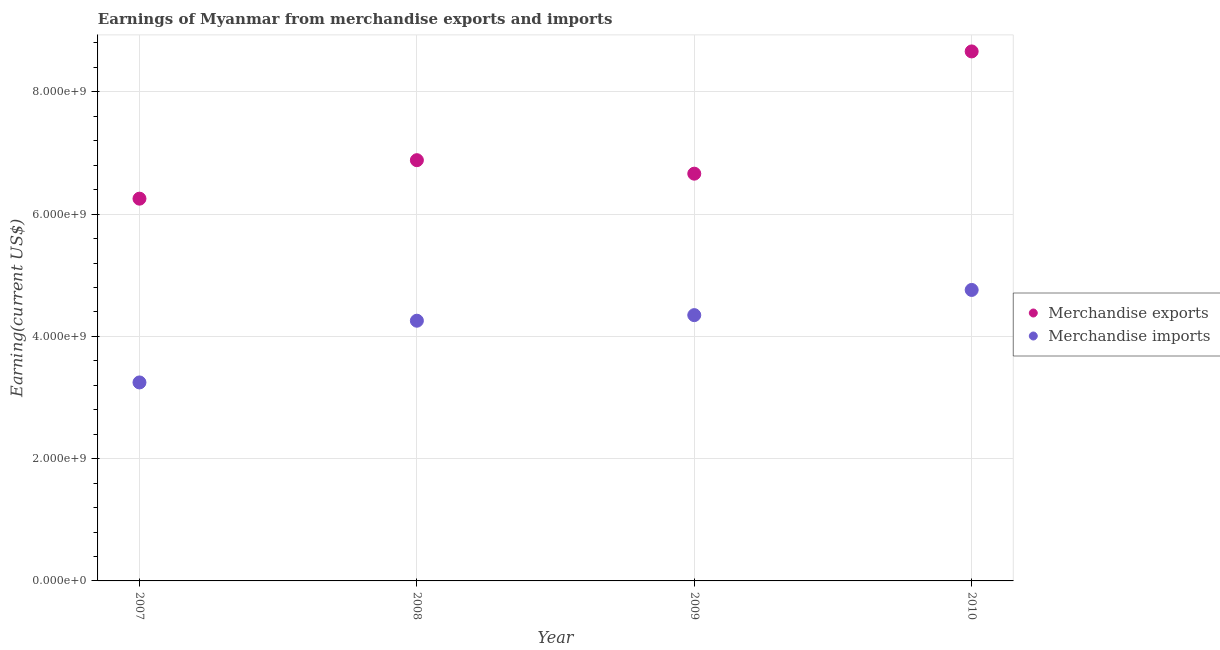How many different coloured dotlines are there?
Ensure brevity in your answer.  2. What is the earnings from merchandise exports in 2010?
Offer a terse response. 8.66e+09. Across all years, what is the maximum earnings from merchandise exports?
Give a very brief answer. 8.66e+09. Across all years, what is the minimum earnings from merchandise imports?
Your response must be concise. 3.25e+09. In which year was the earnings from merchandise exports maximum?
Your response must be concise. 2010. What is the total earnings from merchandise exports in the graph?
Ensure brevity in your answer.  2.85e+1. What is the difference between the earnings from merchandise exports in 2008 and that in 2010?
Keep it short and to the point. -1.78e+09. What is the difference between the earnings from merchandise exports in 2007 and the earnings from merchandise imports in 2010?
Offer a terse response. 1.49e+09. What is the average earnings from merchandise exports per year?
Give a very brief answer. 7.11e+09. In the year 2007, what is the difference between the earnings from merchandise exports and earnings from merchandise imports?
Provide a succinct answer. 3.01e+09. In how many years, is the earnings from merchandise imports greater than 4400000000 US$?
Provide a short and direct response. 1. What is the ratio of the earnings from merchandise imports in 2007 to that in 2008?
Offer a terse response. 0.76. Is the earnings from merchandise exports in 2007 less than that in 2010?
Give a very brief answer. Yes. What is the difference between the highest and the second highest earnings from merchandise exports?
Your answer should be compact. 1.78e+09. What is the difference between the highest and the lowest earnings from merchandise exports?
Your answer should be compact. 2.41e+09. Is the sum of the earnings from merchandise imports in 2008 and 2009 greater than the maximum earnings from merchandise exports across all years?
Ensure brevity in your answer.  No. Does the earnings from merchandise imports monotonically increase over the years?
Ensure brevity in your answer.  Yes. Is the earnings from merchandise exports strictly less than the earnings from merchandise imports over the years?
Ensure brevity in your answer.  No. What is the difference between two consecutive major ticks on the Y-axis?
Ensure brevity in your answer.  2.00e+09. Are the values on the major ticks of Y-axis written in scientific E-notation?
Ensure brevity in your answer.  Yes. Does the graph contain grids?
Provide a succinct answer. Yes. Where does the legend appear in the graph?
Offer a terse response. Center right. What is the title of the graph?
Ensure brevity in your answer.  Earnings of Myanmar from merchandise exports and imports. What is the label or title of the Y-axis?
Your response must be concise. Earning(current US$). What is the Earning(current US$) in Merchandise exports in 2007?
Provide a short and direct response. 6.25e+09. What is the Earning(current US$) in Merchandise imports in 2007?
Your response must be concise. 3.25e+09. What is the Earning(current US$) of Merchandise exports in 2008?
Make the answer very short. 6.88e+09. What is the Earning(current US$) in Merchandise imports in 2008?
Your response must be concise. 4.26e+09. What is the Earning(current US$) in Merchandise exports in 2009?
Make the answer very short. 6.66e+09. What is the Earning(current US$) in Merchandise imports in 2009?
Provide a short and direct response. 4.35e+09. What is the Earning(current US$) of Merchandise exports in 2010?
Offer a very short reply. 8.66e+09. What is the Earning(current US$) of Merchandise imports in 2010?
Offer a terse response. 4.76e+09. Across all years, what is the maximum Earning(current US$) in Merchandise exports?
Give a very brief answer. 8.66e+09. Across all years, what is the maximum Earning(current US$) in Merchandise imports?
Offer a very short reply. 4.76e+09. Across all years, what is the minimum Earning(current US$) of Merchandise exports?
Your answer should be very brief. 6.25e+09. Across all years, what is the minimum Earning(current US$) in Merchandise imports?
Your response must be concise. 3.25e+09. What is the total Earning(current US$) in Merchandise exports in the graph?
Your answer should be compact. 2.85e+1. What is the total Earning(current US$) of Merchandise imports in the graph?
Provide a short and direct response. 1.66e+1. What is the difference between the Earning(current US$) in Merchandise exports in 2007 and that in 2008?
Provide a succinct answer. -6.30e+08. What is the difference between the Earning(current US$) of Merchandise imports in 2007 and that in 2008?
Your response must be concise. -1.01e+09. What is the difference between the Earning(current US$) in Merchandise exports in 2007 and that in 2009?
Keep it short and to the point. -4.09e+08. What is the difference between the Earning(current US$) in Merchandise imports in 2007 and that in 2009?
Offer a terse response. -1.10e+09. What is the difference between the Earning(current US$) in Merchandise exports in 2007 and that in 2010?
Offer a terse response. -2.41e+09. What is the difference between the Earning(current US$) in Merchandise imports in 2007 and that in 2010?
Offer a terse response. -1.51e+09. What is the difference between the Earning(current US$) in Merchandise exports in 2008 and that in 2009?
Your answer should be very brief. 2.21e+08. What is the difference between the Earning(current US$) of Merchandise imports in 2008 and that in 2009?
Give a very brief answer. -9.14e+07. What is the difference between the Earning(current US$) in Merchandise exports in 2008 and that in 2010?
Your answer should be very brief. -1.78e+09. What is the difference between the Earning(current US$) in Merchandise imports in 2008 and that in 2010?
Give a very brief answer. -5.03e+08. What is the difference between the Earning(current US$) in Merchandise exports in 2009 and that in 2010?
Make the answer very short. -2.00e+09. What is the difference between the Earning(current US$) of Merchandise imports in 2009 and that in 2010?
Provide a short and direct response. -4.12e+08. What is the difference between the Earning(current US$) of Merchandise exports in 2007 and the Earning(current US$) of Merchandise imports in 2008?
Offer a very short reply. 2.00e+09. What is the difference between the Earning(current US$) in Merchandise exports in 2007 and the Earning(current US$) in Merchandise imports in 2009?
Offer a very short reply. 1.91e+09. What is the difference between the Earning(current US$) in Merchandise exports in 2007 and the Earning(current US$) in Merchandise imports in 2010?
Give a very brief answer. 1.49e+09. What is the difference between the Earning(current US$) of Merchandise exports in 2008 and the Earning(current US$) of Merchandise imports in 2009?
Offer a very short reply. 2.53e+09. What is the difference between the Earning(current US$) of Merchandise exports in 2008 and the Earning(current US$) of Merchandise imports in 2010?
Ensure brevity in your answer.  2.12e+09. What is the difference between the Earning(current US$) in Merchandise exports in 2009 and the Earning(current US$) in Merchandise imports in 2010?
Your response must be concise. 1.90e+09. What is the average Earning(current US$) of Merchandise exports per year?
Provide a succinct answer. 7.11e+09. What is the average Earning(current US$) in Merchandise imports per year?
Offer a terse response. 4.15e+09. In the year 2007, what is the difference between the Earning(current US$) of Merchandise exports and Earning(current US$) of Merchandise imports?
Make the answer very short. 3.01e+09. In the year 2008, what is the difference between the Earning(current US$) in Merchandise exports and Earning(current US$) in Merchandise imports?
Keep it short and to the point. 2.63e+09. In the year 2009, what is the difference between the Earning(current US$) in Merchandise exports and Earning(current US$) in Merchandise imports?
Provide a succinct answer. 2.31e+09. In the year 2010, what is the difference between the Earning(current US$) in Merchandise exports and Earning(current US$) in Merchandise imports?
Your response must be concise. 3.90e+09. What is the ratio of the Earning(current US$) in Merchandise exports in 2007 to that in 2008?
Offer a terse response. 0.91. What is the ratio of the Earning(current US$) in Merchandise imports in 2007 to that in 2008?
Provide a succinct answer. 0.76. What is the ratio of the Earning(current US$) in Merchandise exports in 2007 to that in 2009?
Ensure brevity in your answer.  0.94. What is the ratio of the Earning(current US$) of Merchandise imports in 2007 to that in 2009?
Give a very brief answer. 0.75. What is the ratio of the Earning(current US$) in Merchandise exports in 2007 to that in 2010?
Ensure brevity in your answer.  0.72. What is the ratio of the Earning(current US$) of Merchandise imports in 2007 to that in 2010?
Ensure brevity in your answer.  0.68. What is the ratio of the Earning(current US$) in Merchandise exports in 2008 to that in 2009?
Provide a succinct answer. 1.03. What is the ratio of the Earning(current US$) of Merchandise exports in 2008 to that in 2010?
Keep it short and to the point. 0.79. What is the ratio of the Earning(current US$) in Merchandise imports in 2008 to that in 2010?
Your response must be concise. 0.89. What is the ratio of the Earning(current US$) of Merchandise exports in 2009 to that in 2010?
Give a very brief answer. 0.77. What is the ratio of the Earning(current US$) of Merchandise imports in 2009 to that in 2010?
Provide a short and direct response. 0.91. What is the difference between the highest and the second highest Earning(current US$) in Merchandise exports?
Your answer should be compact. 1.78e+09. What is the difference between the highest and the second highest Earning(current US$) of Merchandise imports?
Make the answer very short. 4.12e+08. What is the difference between the highest and the lowest Earning(current US$) of Merchandise exports?
Make the answer very short. 2.41e+09. What is the difference between the highest and the lowest Earning(current US$) of Merchandise imports?
Your answer should be very brief. 1.51e+09. 